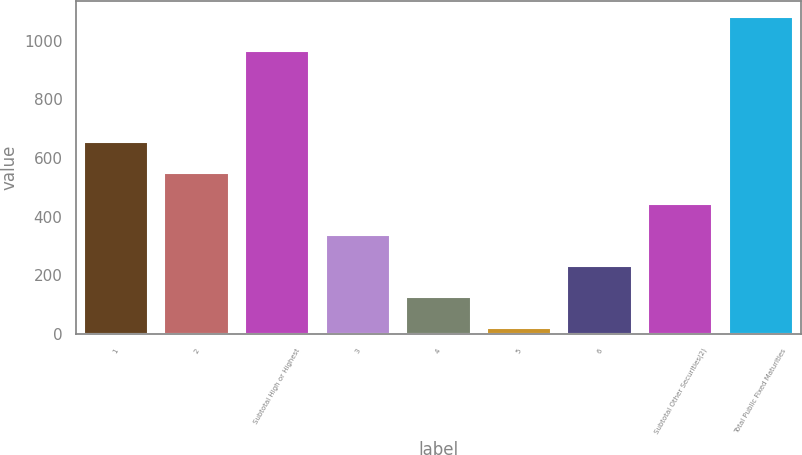Convert chart. <chart><loc_0><loc_0><loc_500><loc_500><bar_chart><fcel>1<fcel>2<fcel>Subtotal High or Highest<fcel>3<fcel>4<fcel>5<fcel>6<fcel>Subtotal Other Securities(2)<fcel>Total Public Fixed Maturities<nl><fcel>656.2<fcel>550<fcel>964<fcel>337.6<fcel>125.2<fcel>19<fcel>231.4<fcel>443.8<fcel>1081<nl></chart> 